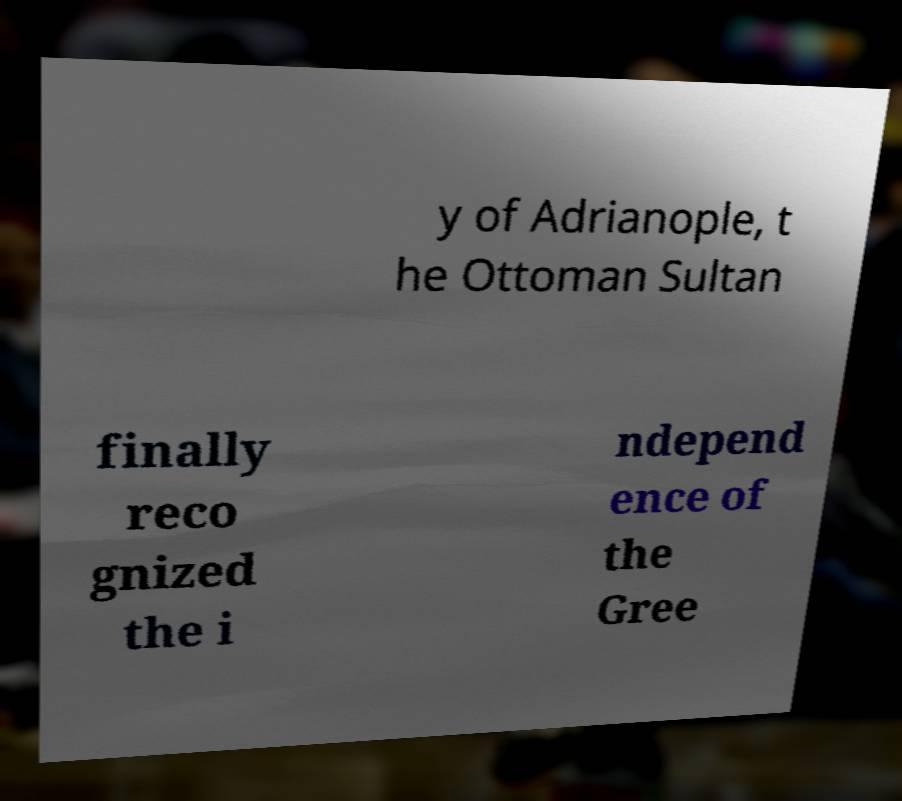Can you read and provide the text displayed in the image?This photo seems to have some interesting text. Can you extract and type it out for me? y of Adrianople, t he Ottoman Sultan finally reco gnized the i ndepend ence of the Gree 